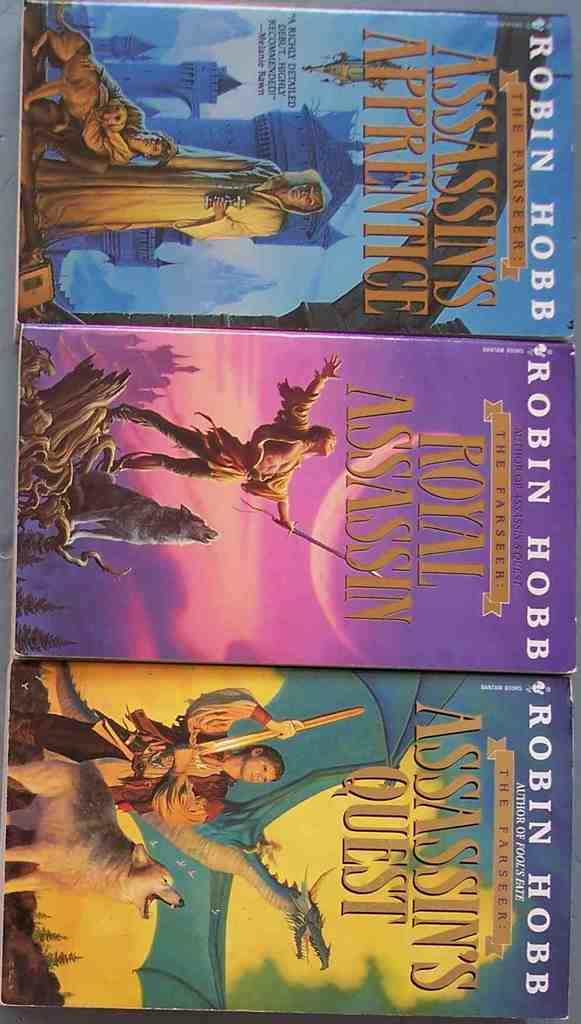<image>
Provide a brief description of the given image. A trio of Robin Hobb paperbacks are arranged one next to the other. 